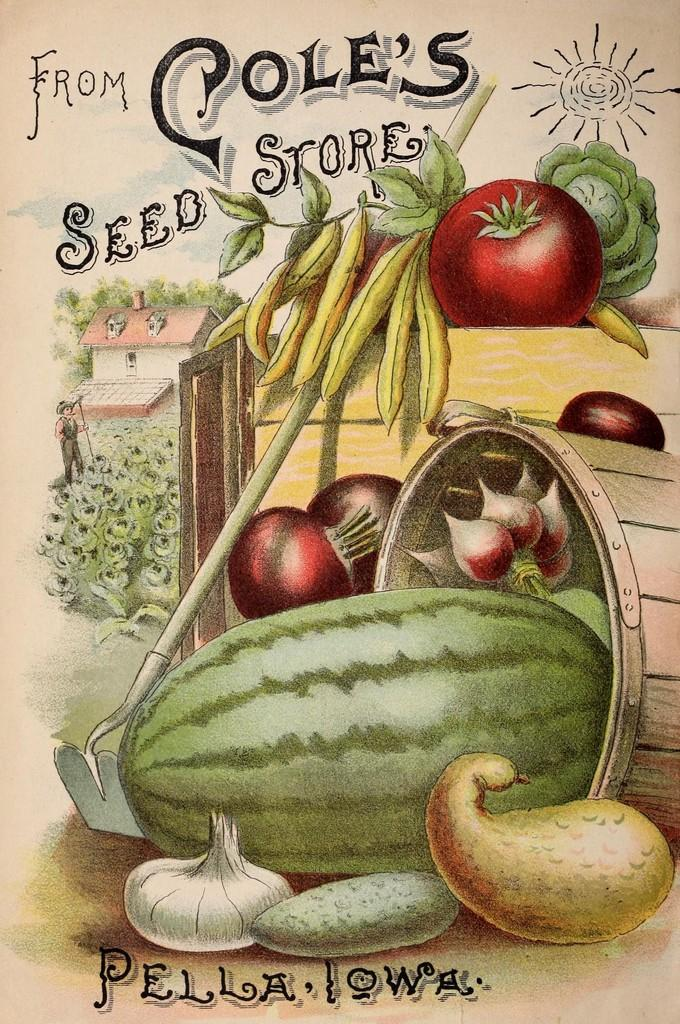What is depicted on the poster in the image? There is a poster with fruits and vegetables in the image. How are the fruits and vegetables arranged in the image? The fruits and vegetables are in a basket. What type of vegetation can be seen in the image? There are plants and trees in the image. What type of structure is visible in the image? There is a house in the image. What type of ring is being exchanged between the plants in the image? There is no ring present in the image, nor is there any indication of an exchange between the plants. 